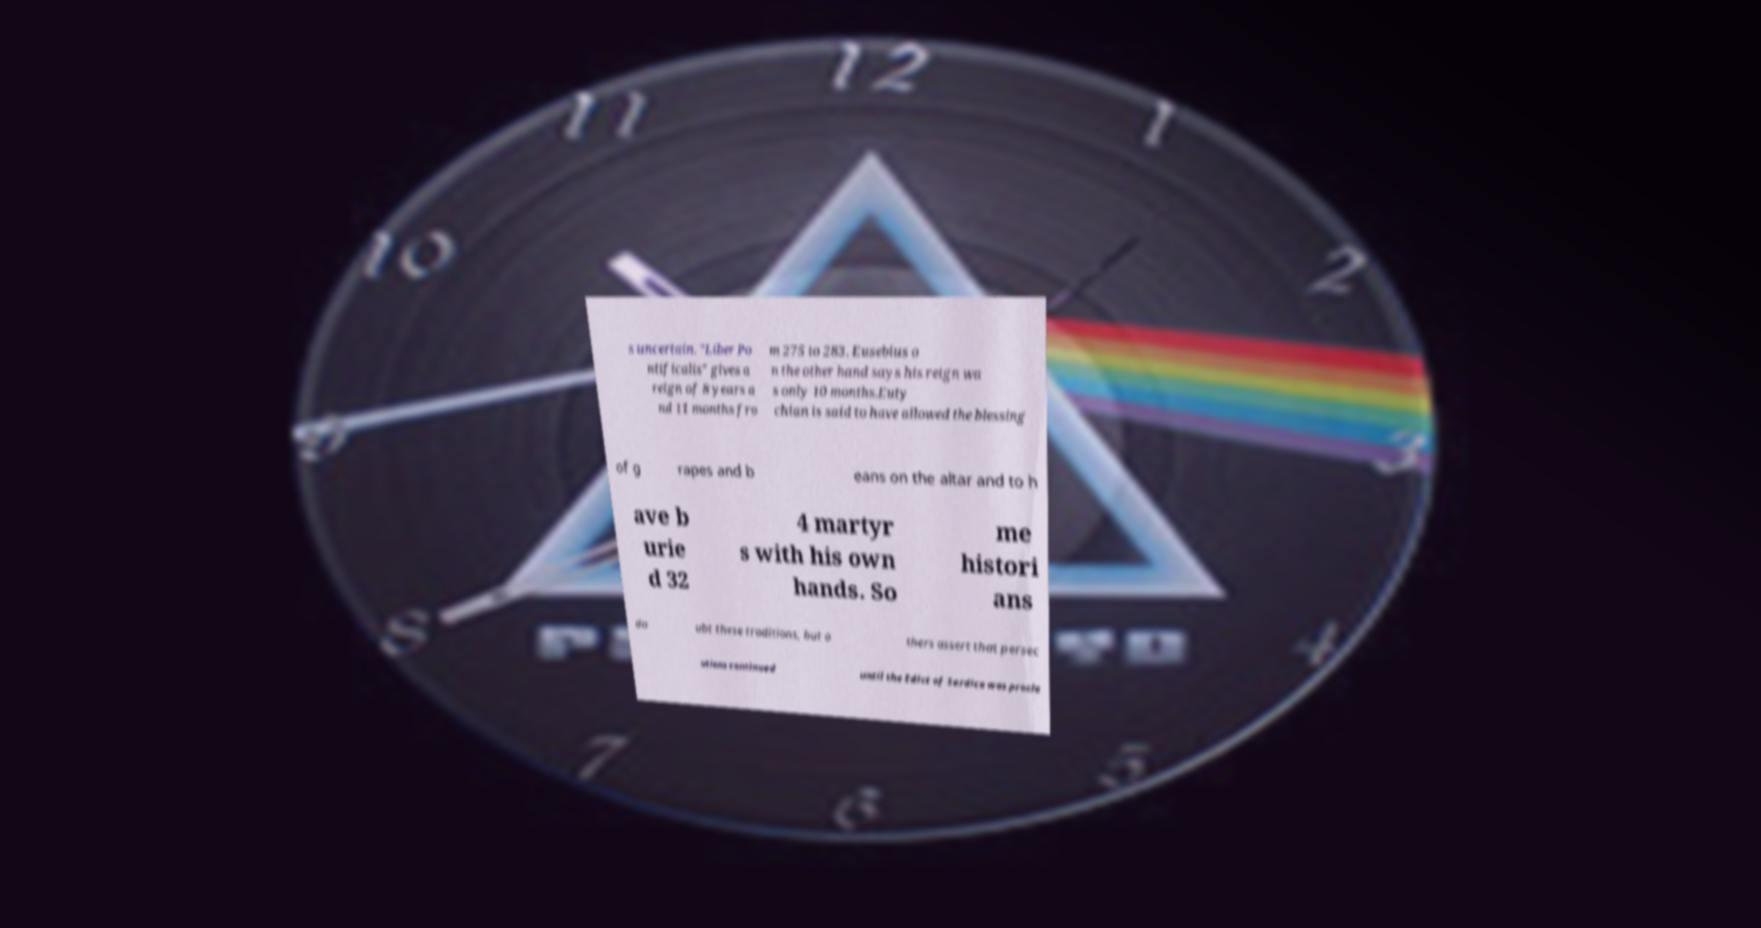I need the written content from this picture converted into text. Can you do that? s uncertain. "Liber Po ntificalis" gives a reign of 8 years a nd 11 months fro m 275 to 283. Eusebius o n the other hand says his reign wa s only 10 months.Euty chian is said to have allowed the blessing of g rapes and b eans on the altar and to h ave b urie d 32 4 martyr s with his own hands. So me histori ans do ubt these traditions, but o thers assert that persec utions continued until the Edict of Serdica was procla 